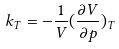Convert formula to latex. <formula><loc_0><loc_0><loc_500><loc_500>k _ { T } = - \frac { 1 } { V } ( \frac { \partial V } { \partial p } ) _ { T }</formula> 